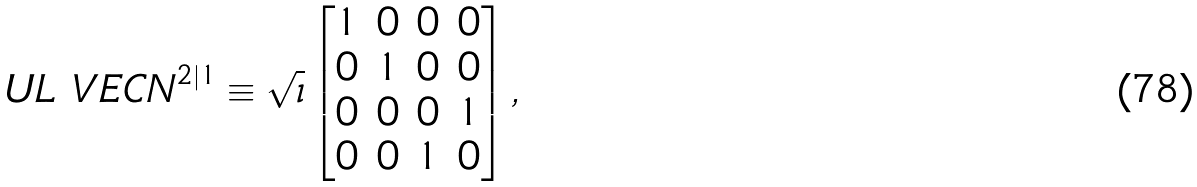Convert formula to latex. <formula><loc_0><loc_0><loc_500><loc_500>\ U L { \ V E C N } ^ { 2 | 1 } \equiv \sqrt { \imath } \begin{bmatrix} 1 & 0 & 0 & 0 \\ 0 & 1 & 0 & 0 \\ 0 & 0 & 0 & 1 \\ 0 & 0 & 1 & 0 \end{bmatrix} ,</formula> 